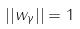<formula> <loc_0><loc_0><loc_500><loc_500>| | w _ { \gamma } | | = 1</formula> 